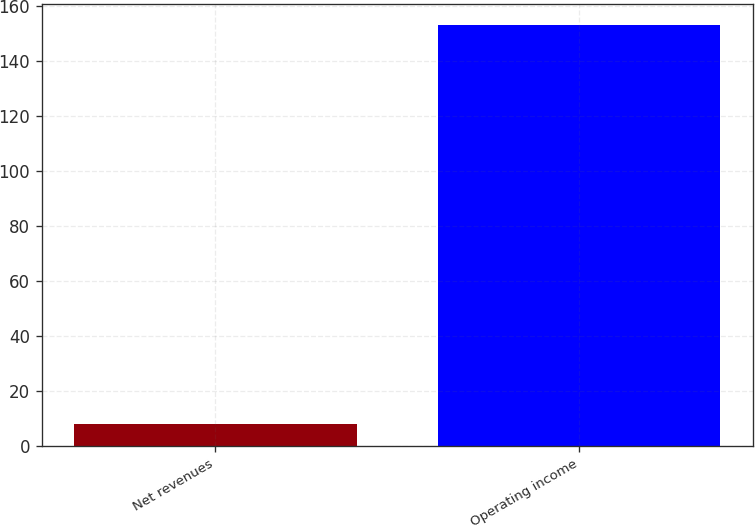Convert chart. <chart><loc_0><loc_0><loc_500><loc_500><bar_chart><fcel>Net revenues<fcel>Operating income<nl><fcel>8<fcel>153<nl></chart> 